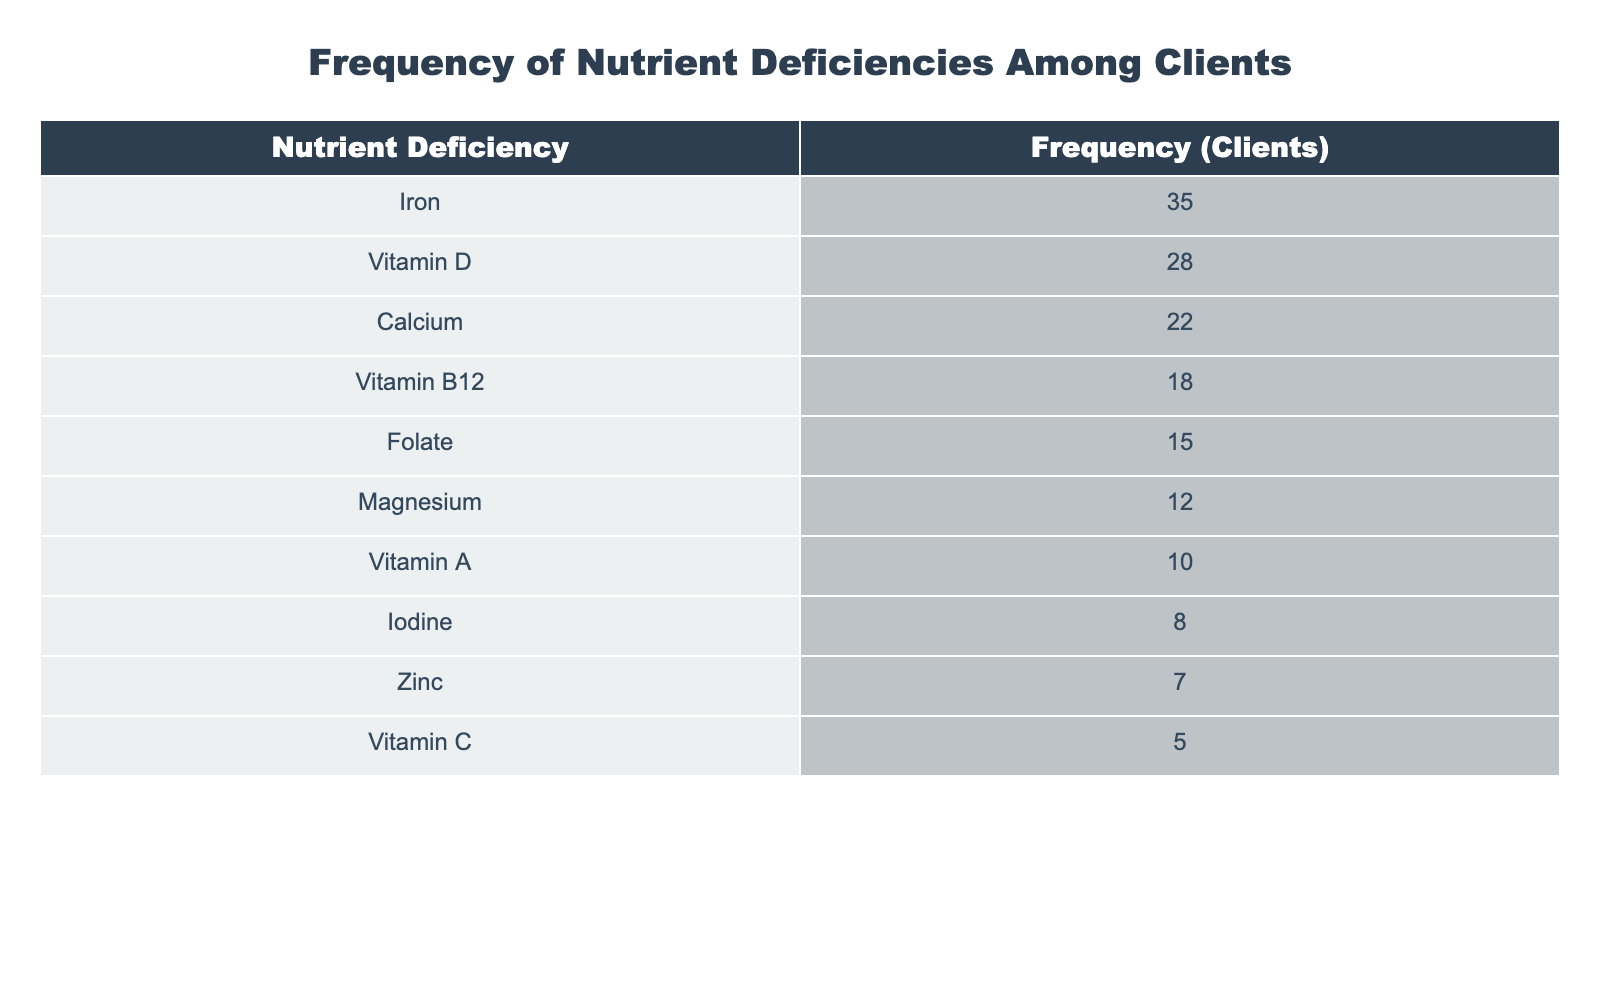What is the highest frequency of nutrient deficiency among clients? The table shows that Iron has the highest frequency with 35 clients reporting a deficiency.
Answer: 35 How many clients reported a deficiency in Vitamin D? The table indicates that 28 clients have reported a deficiency in Vitamin D.
Answer: 28 What is the total number of clients with deficiencies in Calcium and Vitamin B12 combined? The frequency of clients with Calcium deficiencies is 22 and with Vitamin B12 is 18. Adding these together gives 22 + 18 = 40.
Answer: 40 Is the frequency of Zinc deficiency higher than that of Vitamin C deficiency? Zinc has a frequency of 7 clients while Vitamin C has a frequency of 5 clients. Since 7 is greater than 5, the statement is true.
Answer: Yes What is the average frequency of nutrient deficiencies among all clients listed? To find the average, sum all the frequencies: 35 + 28 + 22 + 18 + 15 + 12 + 10 + 8 + 7 + 5 =  160. There are 10 nutrients listed, so the average is 160/10 = 16.
Answer: 16 Which nutrient deficiencies have a frequency of 15 or fewer clients? The nutrients with 15 or fewer deficiencies are Folate (15), Magnesium (12), Vitamin A (10), Iodine (8), Zinc (7), and Vitamin C (5).
Answer: Folate, Magnesium, Vitamin A, Iodine, Zinc, Vitamin C How many more clients reported a deficiency in Iron compared to that of Iodine? The frequency of Iron deficiency is 35, and for Iodine, it is 8. The difference is calculated by subtracting: 35 - 8 = 27.
Answer: 27 Is the total number of clients deficient in Vitamin D and Calcium greater than those deficient in Iron? The combined deficiencies in Vitamin D and Calcium are 28 + 22 = 50. The frequency for Iron deficiencies is 35. Since 50 is greater than 35, the statement is true.
Answer: Yes Which nutrients appear to be the least deficient among clients based on the data? The nutrients with the least reported deficiencies are Vitamin C (5) and Zinc (7), which have the lowest frequencies in the table.
Answer: Vitamin C, Zinc 